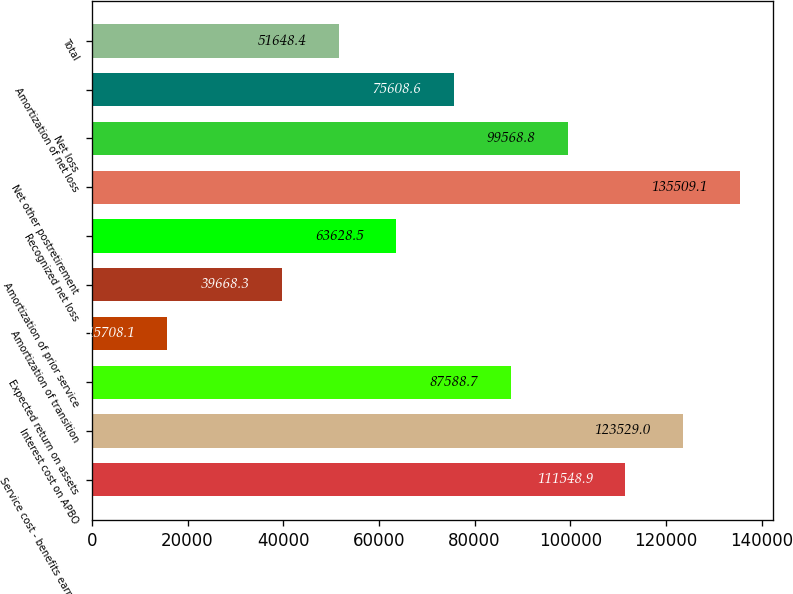Convert chart to OTSL. <chart><loc_0><loc_0><loc_500><loc_500><bar_chart><fcel>Service cost - benefits earned<fcel>Interest cost on APBO<fcel>Expected return on assets<fcel>Amortization of transition<fcel>Amortization of prior service<fcel>Recognized net loss<fcel>Net other postretirement<fcel>Net loss<fcel>Amortization of net loss<fcel>Total<nl><fcel>111549<fcel>123529<fcel>87588.7<fcel>15708.1<fcel>39668.3<fcel>63628.5<fcel>135509<fcel>99568.8<fcel>75608.6<fcel>51648.4<nl></chart> 